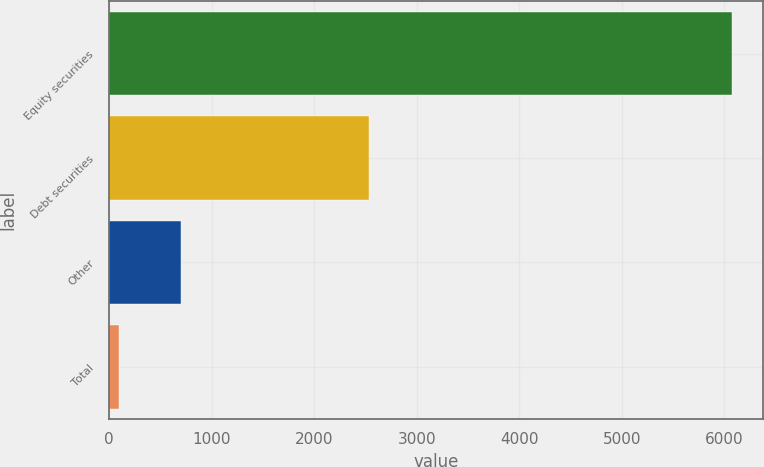Convert chart. <chart><loc_0><loc_0><loc_500><loc_500><bar_chart><fcel>Equity securities<fcel>Debt securities<fcel>Other<fcel>Total<nl><fcel>6070<fcel>2535<fcel>697<fcel>100<nl></chart> 